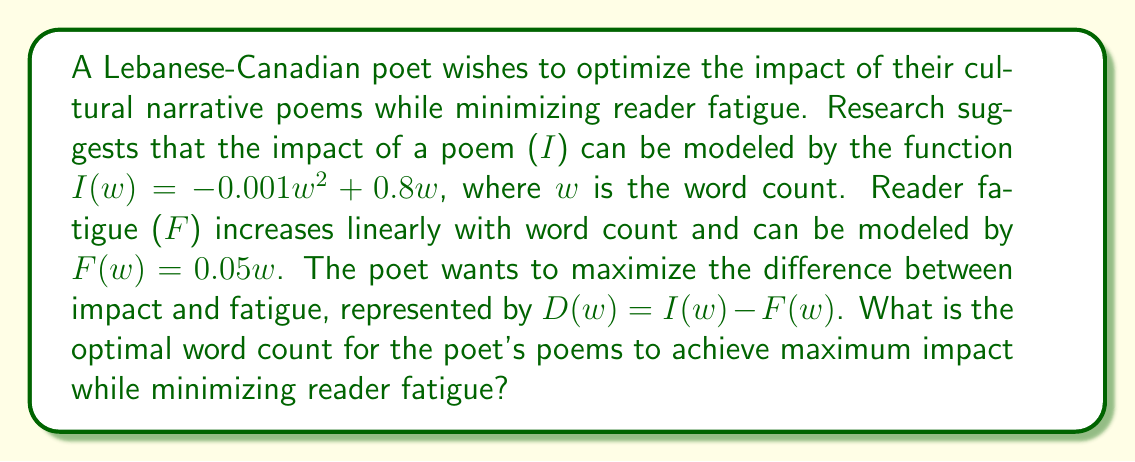Can you answer this question? To solve this optimization problem, we need to follow these steps:

1) First, let's define the function $D(w)$ that we want to maximize:

   $D(w) = I(w) - F(w)$
   $D(w) = (-0.001w^2 + 0.8w) - 0.05w$
   $D(w) = -0.001w^2 + 0.75w$

2) To find the maximum of this function, we need to find where its derivative equals zero:

   $\frac{d}{dw}D(w) = -0.002w + 0.75$

3) Set this equal to zero and solve for $w$:

   $-0.002w + 0.75 = 0$
   $-0.002w = -0.75$
   $w = 375$

4) To confirm this is a maximum (not a minimum), we can check the second derivative:

   $\frac{d^2}{dw^2}D(w) = -0.002$

   Since this is negative, we confirm that $w = 375$ gives a maximum.

5) We can verify that this result makes sense in the context of the problem. At 375 words:

   Impact: $I(375) = -0.001(375)^2 + 0.8(375) = 140.625$
   Fatigue: $F(375) = 0.05(375) = 18.75$
   Difference: $D(375) = 140.625 - 18.75 = 121.875$

This is indeed the maximum value for $D(w)$.
Answer: The optimal word count for the poet's cultural narrative poems is 375 words. This maximizes the difference between impact and reader fatigue at 121.875 units. 